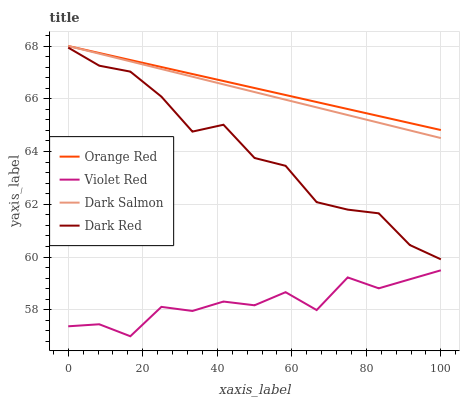Does Violet Red have the minimum area under the curve?
Answer yes or no. Yes. Does Orange Red have the maximum area under the curve?
Answer yes or no. Yes. Does Orange Red have the minimum area under the curve?
Answer yes or no. No. Does Violet Red have the maximum area under the curve?
Answer yes or no. No. Is Orange Red the smoothest?
Answer yes or no. Yes. Is Violet Red the roughest?
Answer yes or no. Yes. Is Violet Red the smoothest?
Answer yes or no. No. Is Orange Red the roughest?
Answer yes or no. No. Does Violet Red have the lowest value?
Answer yes or no. Yes. Does Orange Red have the lowest value?
Answer yes or no. No. Does Dark Salmon have the highest value?
Answer yes or no. Yes. Does Violet Red have the highest value?
Answer yes or no. No. Is Violet Red less than Dark Red?
Answer yes or no. Yes. Is Dark Salmon greater than Dark Red?
Answer yes or no. Yes. Does Orange Red intersect Dark Salmon?
Answer yes or no. Yes. Is Orange Red less than Dark Salmon?
Answer yes or no. No. Is Orange Red greater than Dark Salmon?
Answer yes or no. No. Does Violet Red intersect Dark Red?
Answer yes or no. No. 